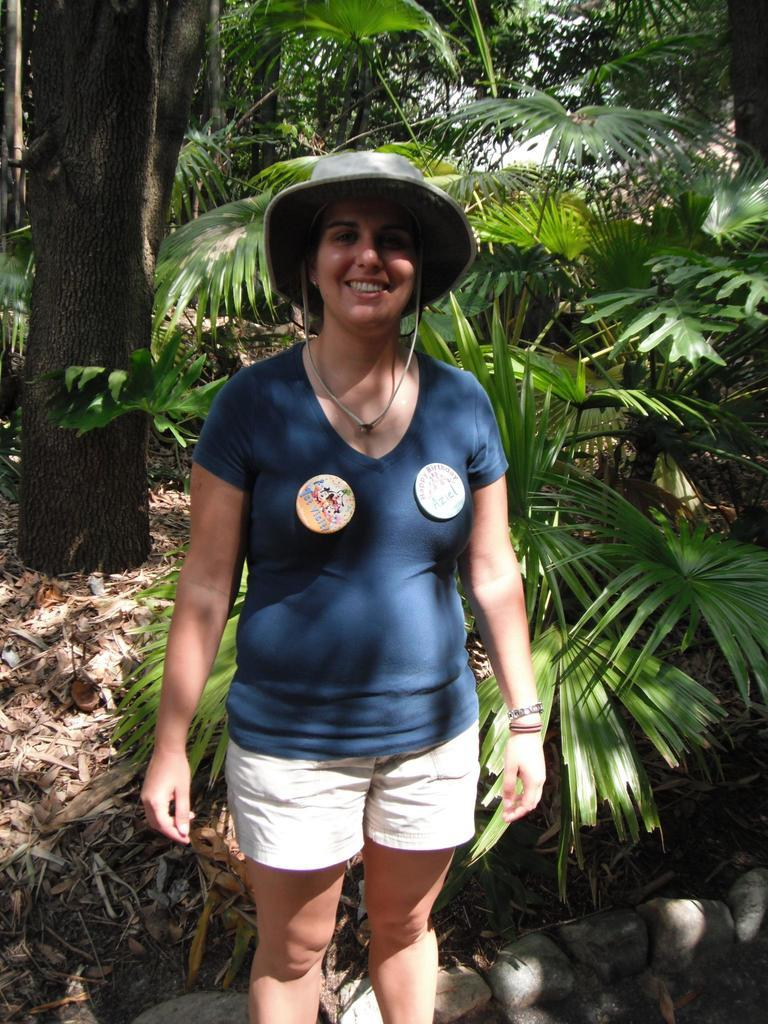What is the main subject of the image? There is a woman standing in the image. What is the woman's position in relation to the ground? The woman is standing on the ground. What can be seen in the background of the image? There are shredded leaves, plants, trees, and the sky visible in the background of the image. What type of cheese is being grated by the grandmother in the image? There is no grandmother or cheese present in the image; it features a woman standing on the ground with a background of shredded leaves, plants, trees, and the sky. 